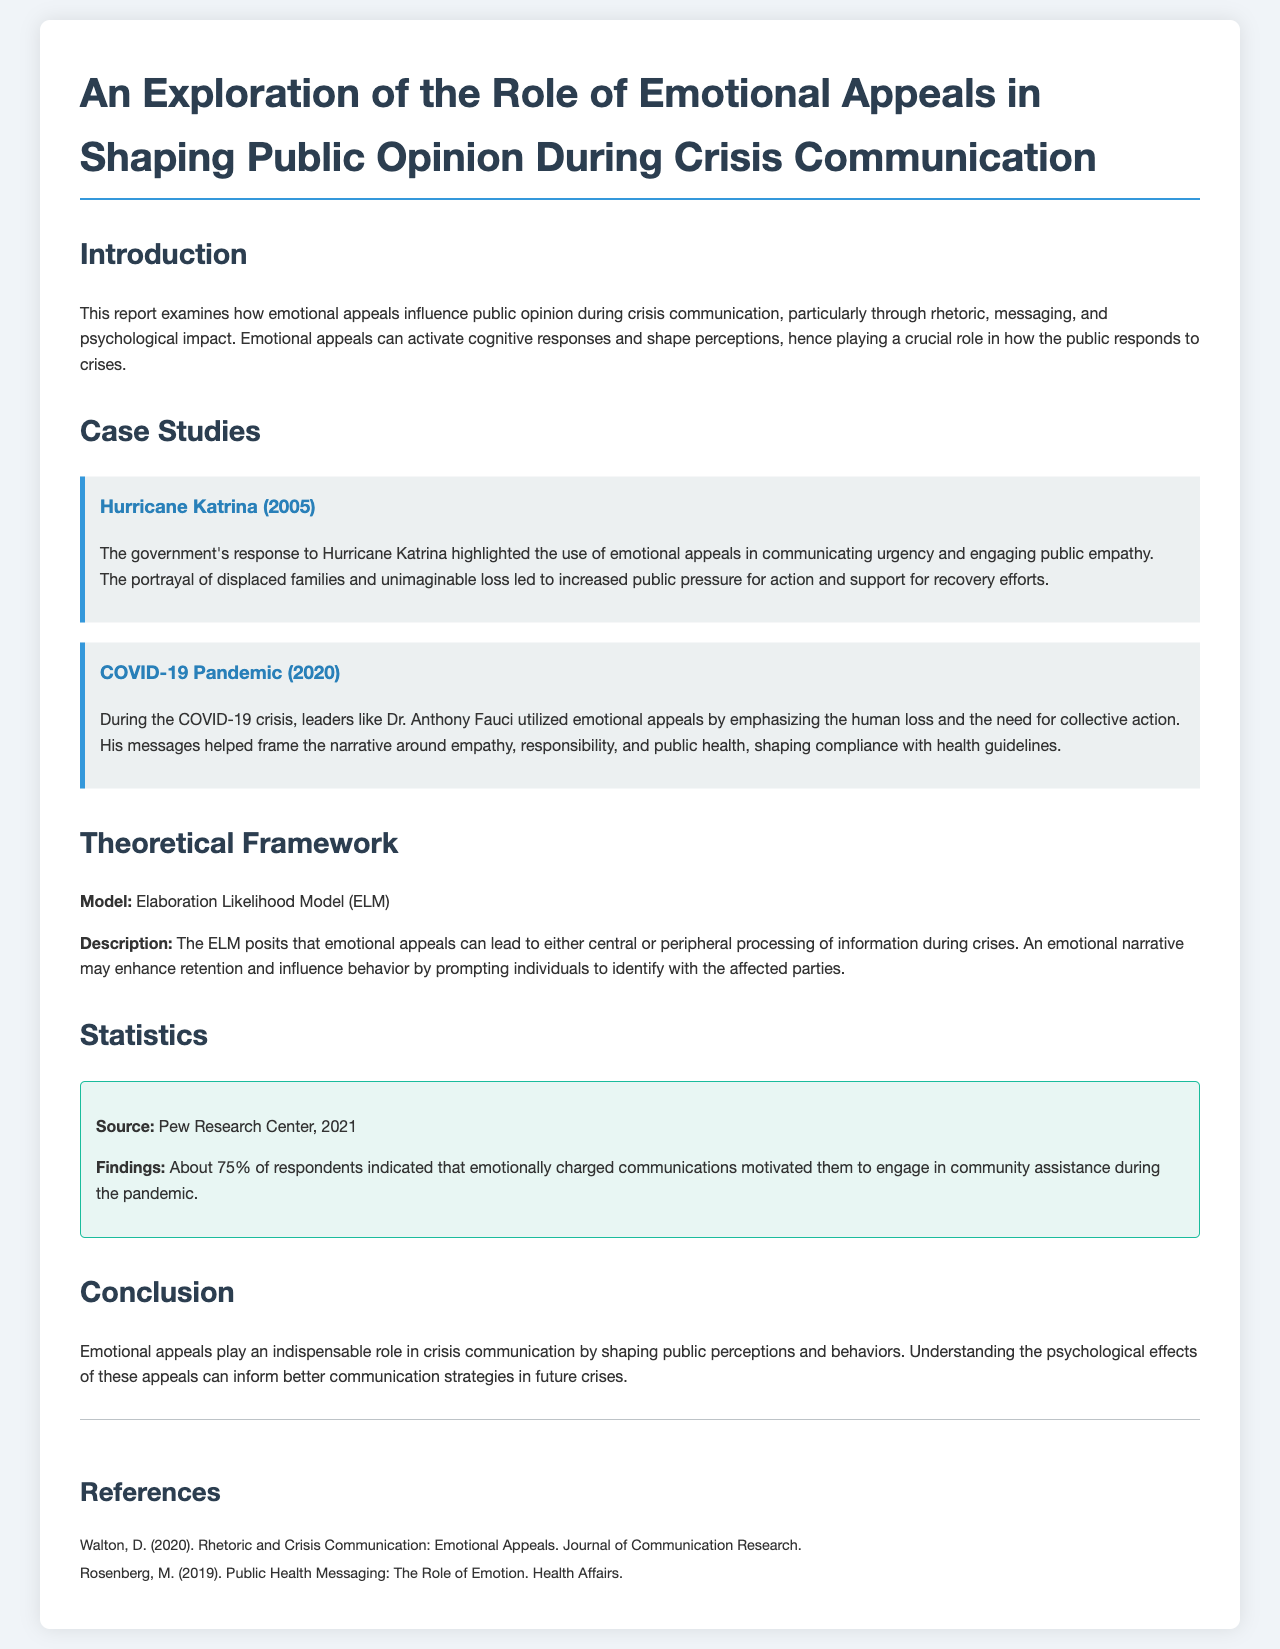What is the title of the report? The title of the report is prominently stated in the header section.
Answer: An Exploration of the Role of Emotional Appeals in Shaping Public Opinion During Crisis Communication In which year did Hurricane Katrina occur? The report specifies the year of Hurricane Katrina in the case study section.
Answer: 2005 Who emphasized emotional appeals during the COVID-19 crisis? The report mentions a specific leader who utilized emotional appeals.
Answer: Dr. Anthony Fauci What percentage of respondents engaged in community assistance due to emotional communications? The report provides statistical data regarding community engagement in the statistics section.
Answer: 75% What model is referenced in the theoretical framework? The theoretical framework portion of the document specifies the model used.
Answer: Elaboration Likelihood Model (ELM) What two themes were emphasized in Dr. Fauci's messaging during the COVID-19 crisis? The document discusses themes identified in the messaging by Dr. Fauci.
Answer: Empathy, responsibility What was the publication year of Walton's referenced paper? The references section lists the publication year of Walton's work.
Answer: 2020 Which organization conducted the study noted in the statistics? The source of the statistics is mentioned in the statistics section of the report.
Answer: Pew Research Center 